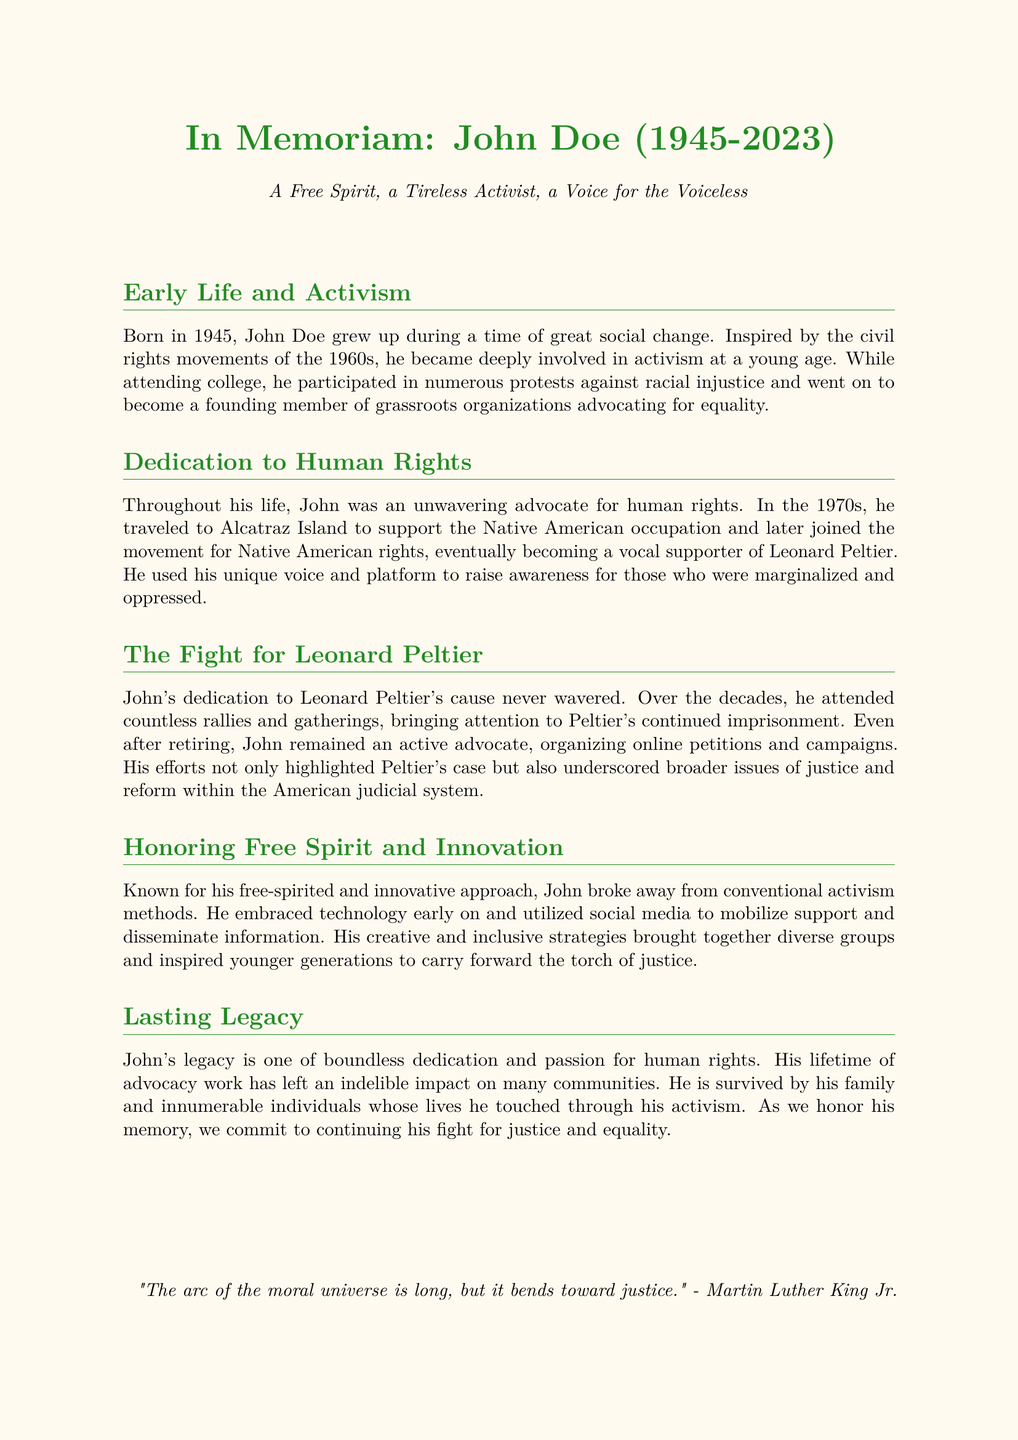What year was John Doe born? John Doe was born in 1945 as stated in the document.
Answer: 1945 What cause did John Doe advocate for in the 1970s? In the 1970s, John Doe supported the Native American movement mentioned in the document.
Answer: Native American rights Who is mentioned as a vocal supporter that John Doe became involved with? Leonard Peltier is referenced as the cause John supported extensively.
Answer: Leonard Peltier What approach did John Doe use for activism? The document notes he broke conventional activism methods and embraced technology early on.
Answer: Innovative What quote is included in the obituary? The obituary includes a quote from Martin Luther King Jr. emphasizing justice.
Answer: "The arc of the moral universe is long, but it bends toward justice." What is John Doe’s designation in the title? The title designates him as "A Free Spirit, a Tireless Activist, a Voice for the Voiceless."
Answer: A Free Spirit, a Tireless Activist, a Voice for the Voiceless What was John Doe's response to retirement regarding activism? The document states that even after retiring, he remained an active advocate.
Answer: Active advocate How did John Doe mobilize support? He utilized social media to mobilize support as mentioned in the document.
Answer: Social media 